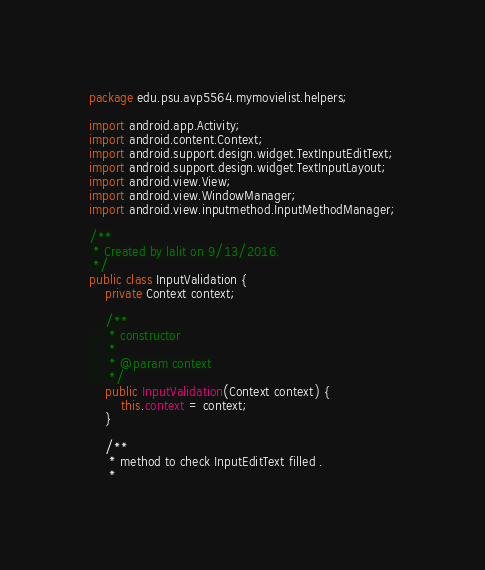<code> <loc_0><loc_0><loc_500><loc_500><_Java_>package edu.psu.avp5564.mymovielist.helpers;

import android.app.Activity;
import android.content.Context;
import android.support.design.widget.TextInputEditText;
import android.support.design.widget.TextInputLayout;
import android.view.View;
import android.view.WindowManager;
import android.view.inputmethod.InputMethodManager;

/**
 * Created by lalit on 9/13/2016.
 */
public class InputValidation {
    private Context context;

    /**
     * constructor
     *
     * @param context
     */
    public InputValidation(Context context) {
        this.context = context;
    }

    /**
     * method to check InputEditText filled .
     *</code> 